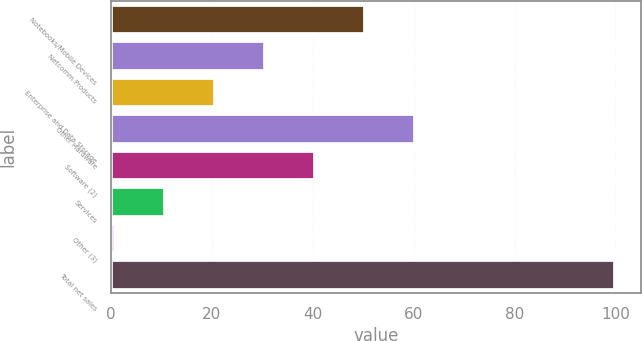<chart> <loc_0><loc_0><loc_500><loc_500><bar_chart><fcel>Notebooks/Mobile Devices<fcel>Netcomm Products<fcel>Enterprise and Data Storage<fcel>Other Hardware<fcel>Software (2)<fcel>Services<fcel>Other (3)<fcel>Total net sales<nl><fcel>50.4<fcel>30.56<fcel>20.64<fcel>60.32<fcel>40.48<fcel>10.72<fcel>0.8<fcel>100<nl></chart> 